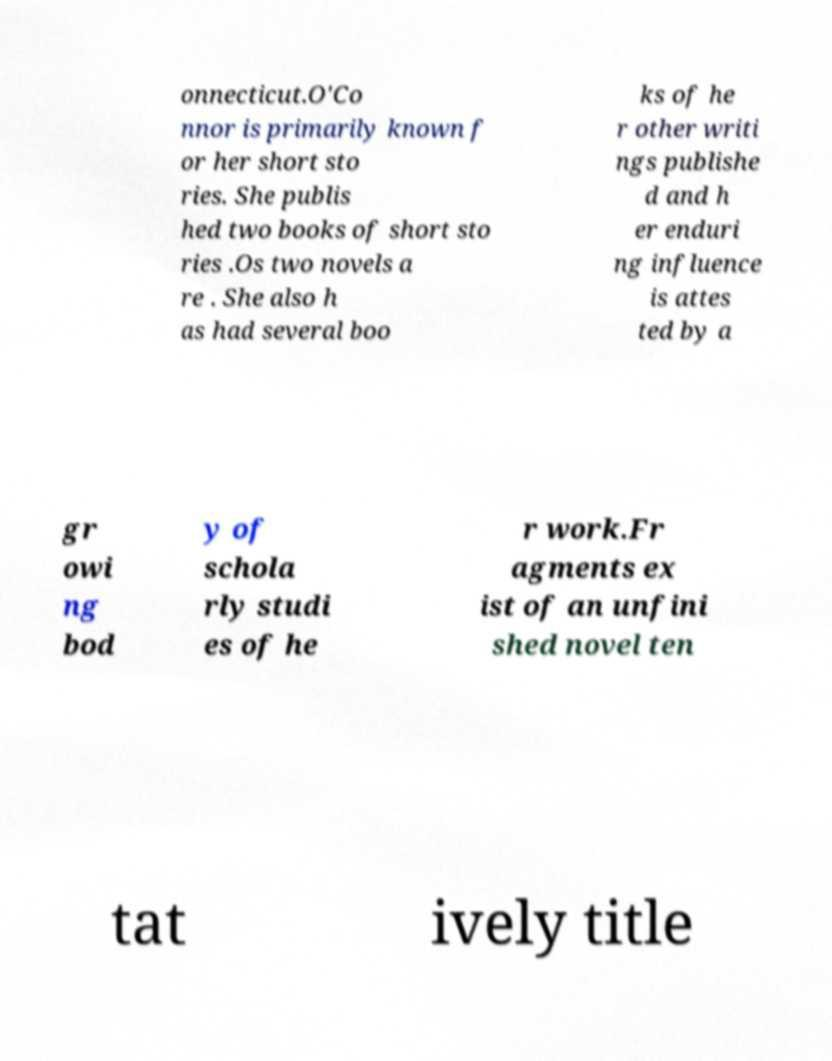Could you extract and type out the text from this image? onnecticut.O'Co nnor is primarily known f or her short sto ries. She publis hed two books of short sto ries .Os two novels a re . She also h as had several boo ks of he r other writi ngs publishe d and h er enduri ng influence is attes ted by a gr owi ng bod y of schola rly studi es of he r work.Fr agments ex ist of an unfini shed novel ten tat ively title 